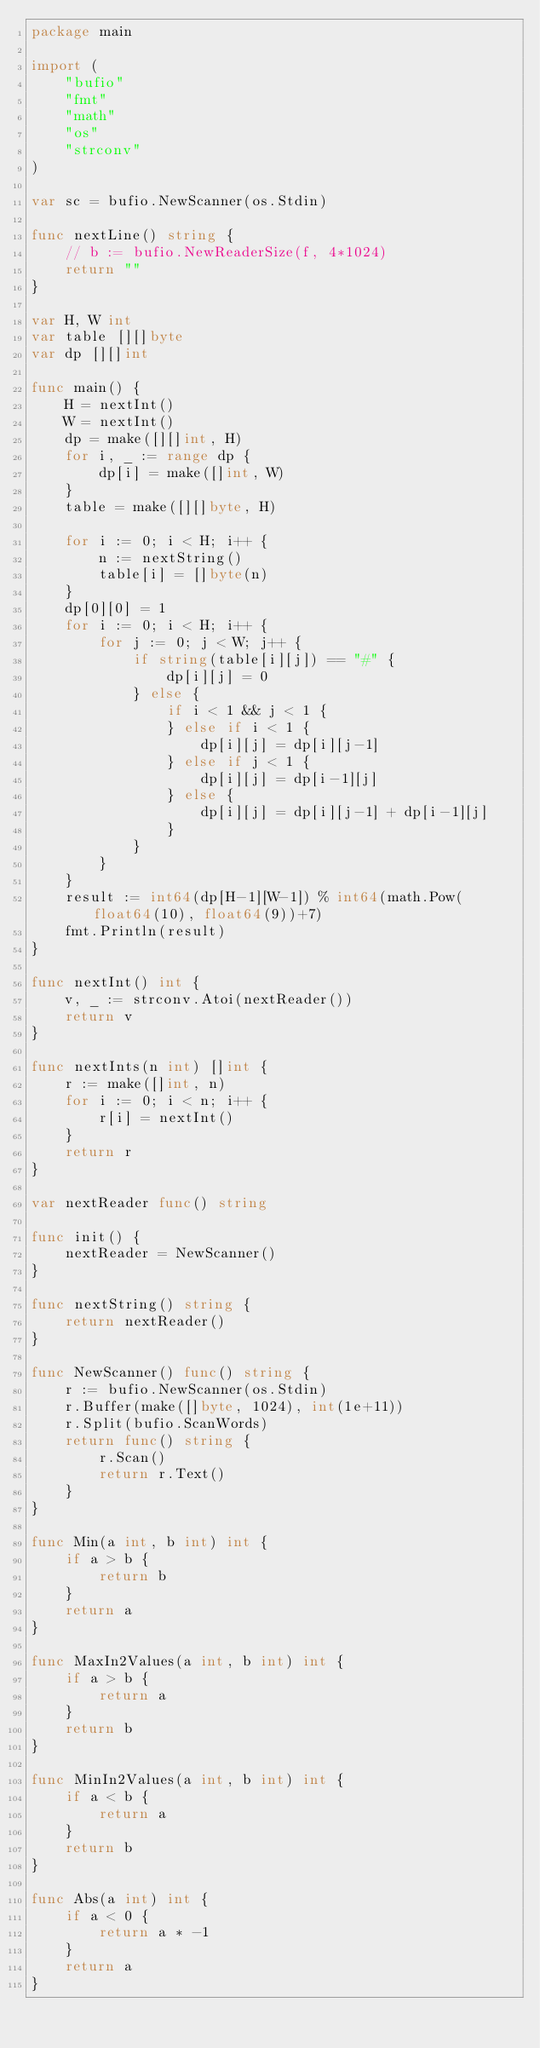<code> <loc_0><loc_0><loc_500><loc_500><_Go_>package main

import (
	"bufio"
	"fmt"
	"math"
	"os"
	"strconv"
)

var sc = bufio.NewScanner(os.Stdin)

func nextLine() string {
	// b := bufio.NewReaderSize(f, 4*1024)
	return ""
}

var H, W int
var table [][]byte
var dp [][]int

func main() {
	H = nextInt()
	W = nextInt()
	dp = make([][]int, H)
	for i, _ := range dp {
		dp[i] = make([]int, W)
	}
	table = make([][]byte, H)

	for i := 0; i < H; i++ {
		n := nextString()
		table[i] = []byte(n)
	}
	dp[0][0] = 1
	for i := 0; i < H; i++ {
		for j := 0; j < W; j++ {
			if string(table[i][j]) == "#" {
				dp[i][j] = 0
			} else {
				if i < 1 && j < 1 {
				} else if i < 1 {
					dp[i][j] = dp[i][j-1]
				} else if j < 1 {
					dp[i][j] = dp[i-1][j]
				} else {
					dp[i][j] = dp[i][j-1] + dp[i-1][j]
				}
			}
		}
	}
	result := int64(dp[H-1][W-1]) % int64(math.Pow(float64(10), float64(9))+7)
	fmt.Println(result)
}

func nextInt() int {
	v, _ := strconv.Atoi(nextReader())
	return v
}

func nextInts(n int) []int {
	r := make([]int, n)
	for i := 0; i < n; i++ {
		r[i] = nextInt()
	}
	return r
}

var nextReader func() string

func init() {
	nextReader = NewScanner()
}

func nextString() string {
	return nextReader()
}

func NewScanner() func() string {
	r := bufio.NewScanner(os.Stdin)
	r.Buffer(make([]byte, 1024), int(1e+11))
	r.Split(bufio.ScanWords)
	return func() string {
		r.Scan()
		return r.Text()
	}
}

func Min(a int, b int) int {
	if a > b {
		return b
	}
	return a
}

func MaxIn2Values(a int, b int) int {
	if a > b {
		return a
	}
	return b
}

func MinIn2Values(a int, b int) int {
	if a < b {
		return a
	}
	return b
}

func Abs(a int) int {
	if a < 0 {
		return a * -1
	}
	return a
}
</code> 